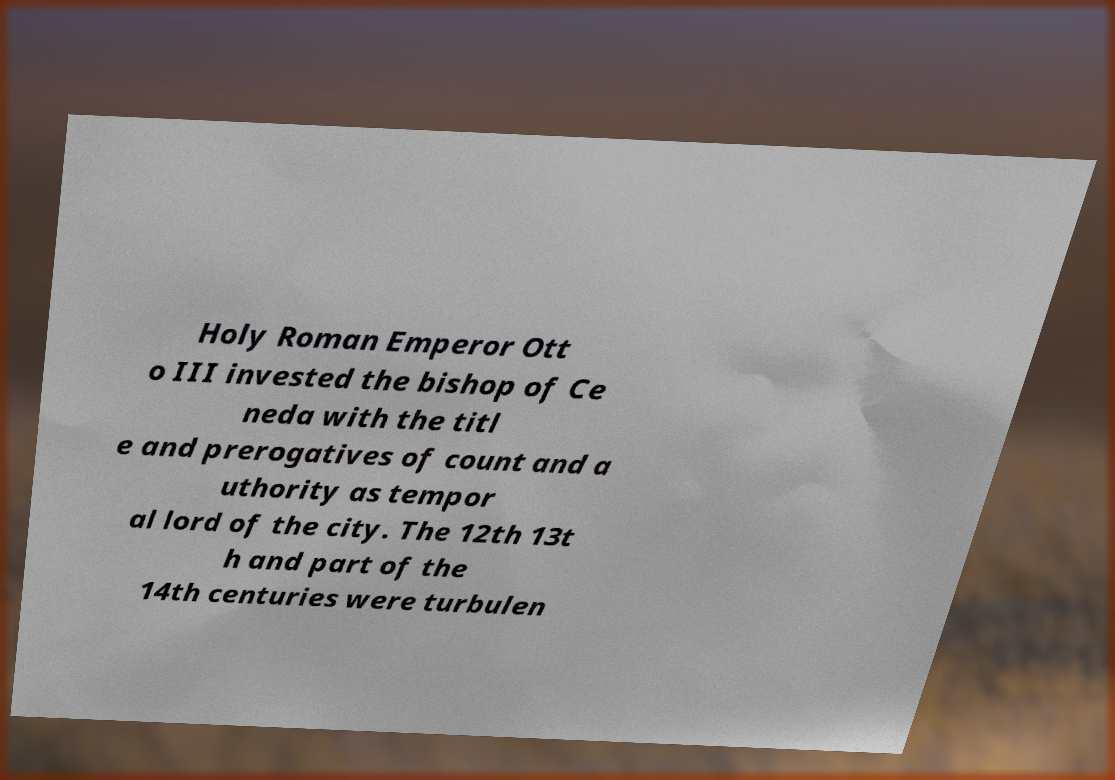I need the written content from this picture converted into text. Can you do that? Holy Roman Emperor Ott o III invested the bishop of Ce neda with the titl e and prerogatives of count and a uthority as tempor al lord of the city. The 12th 13t h and part of the 14th centuries were turbulen 